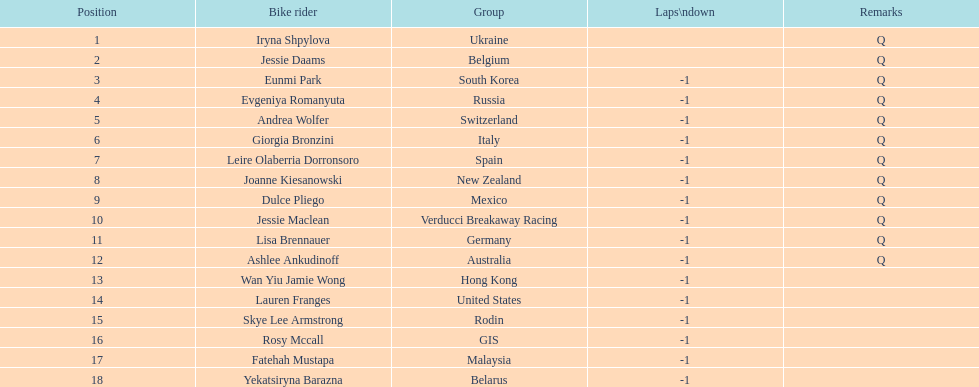What two cyclists come from teams with no laps down? Iryna Shpylova, Jessie Daams. 